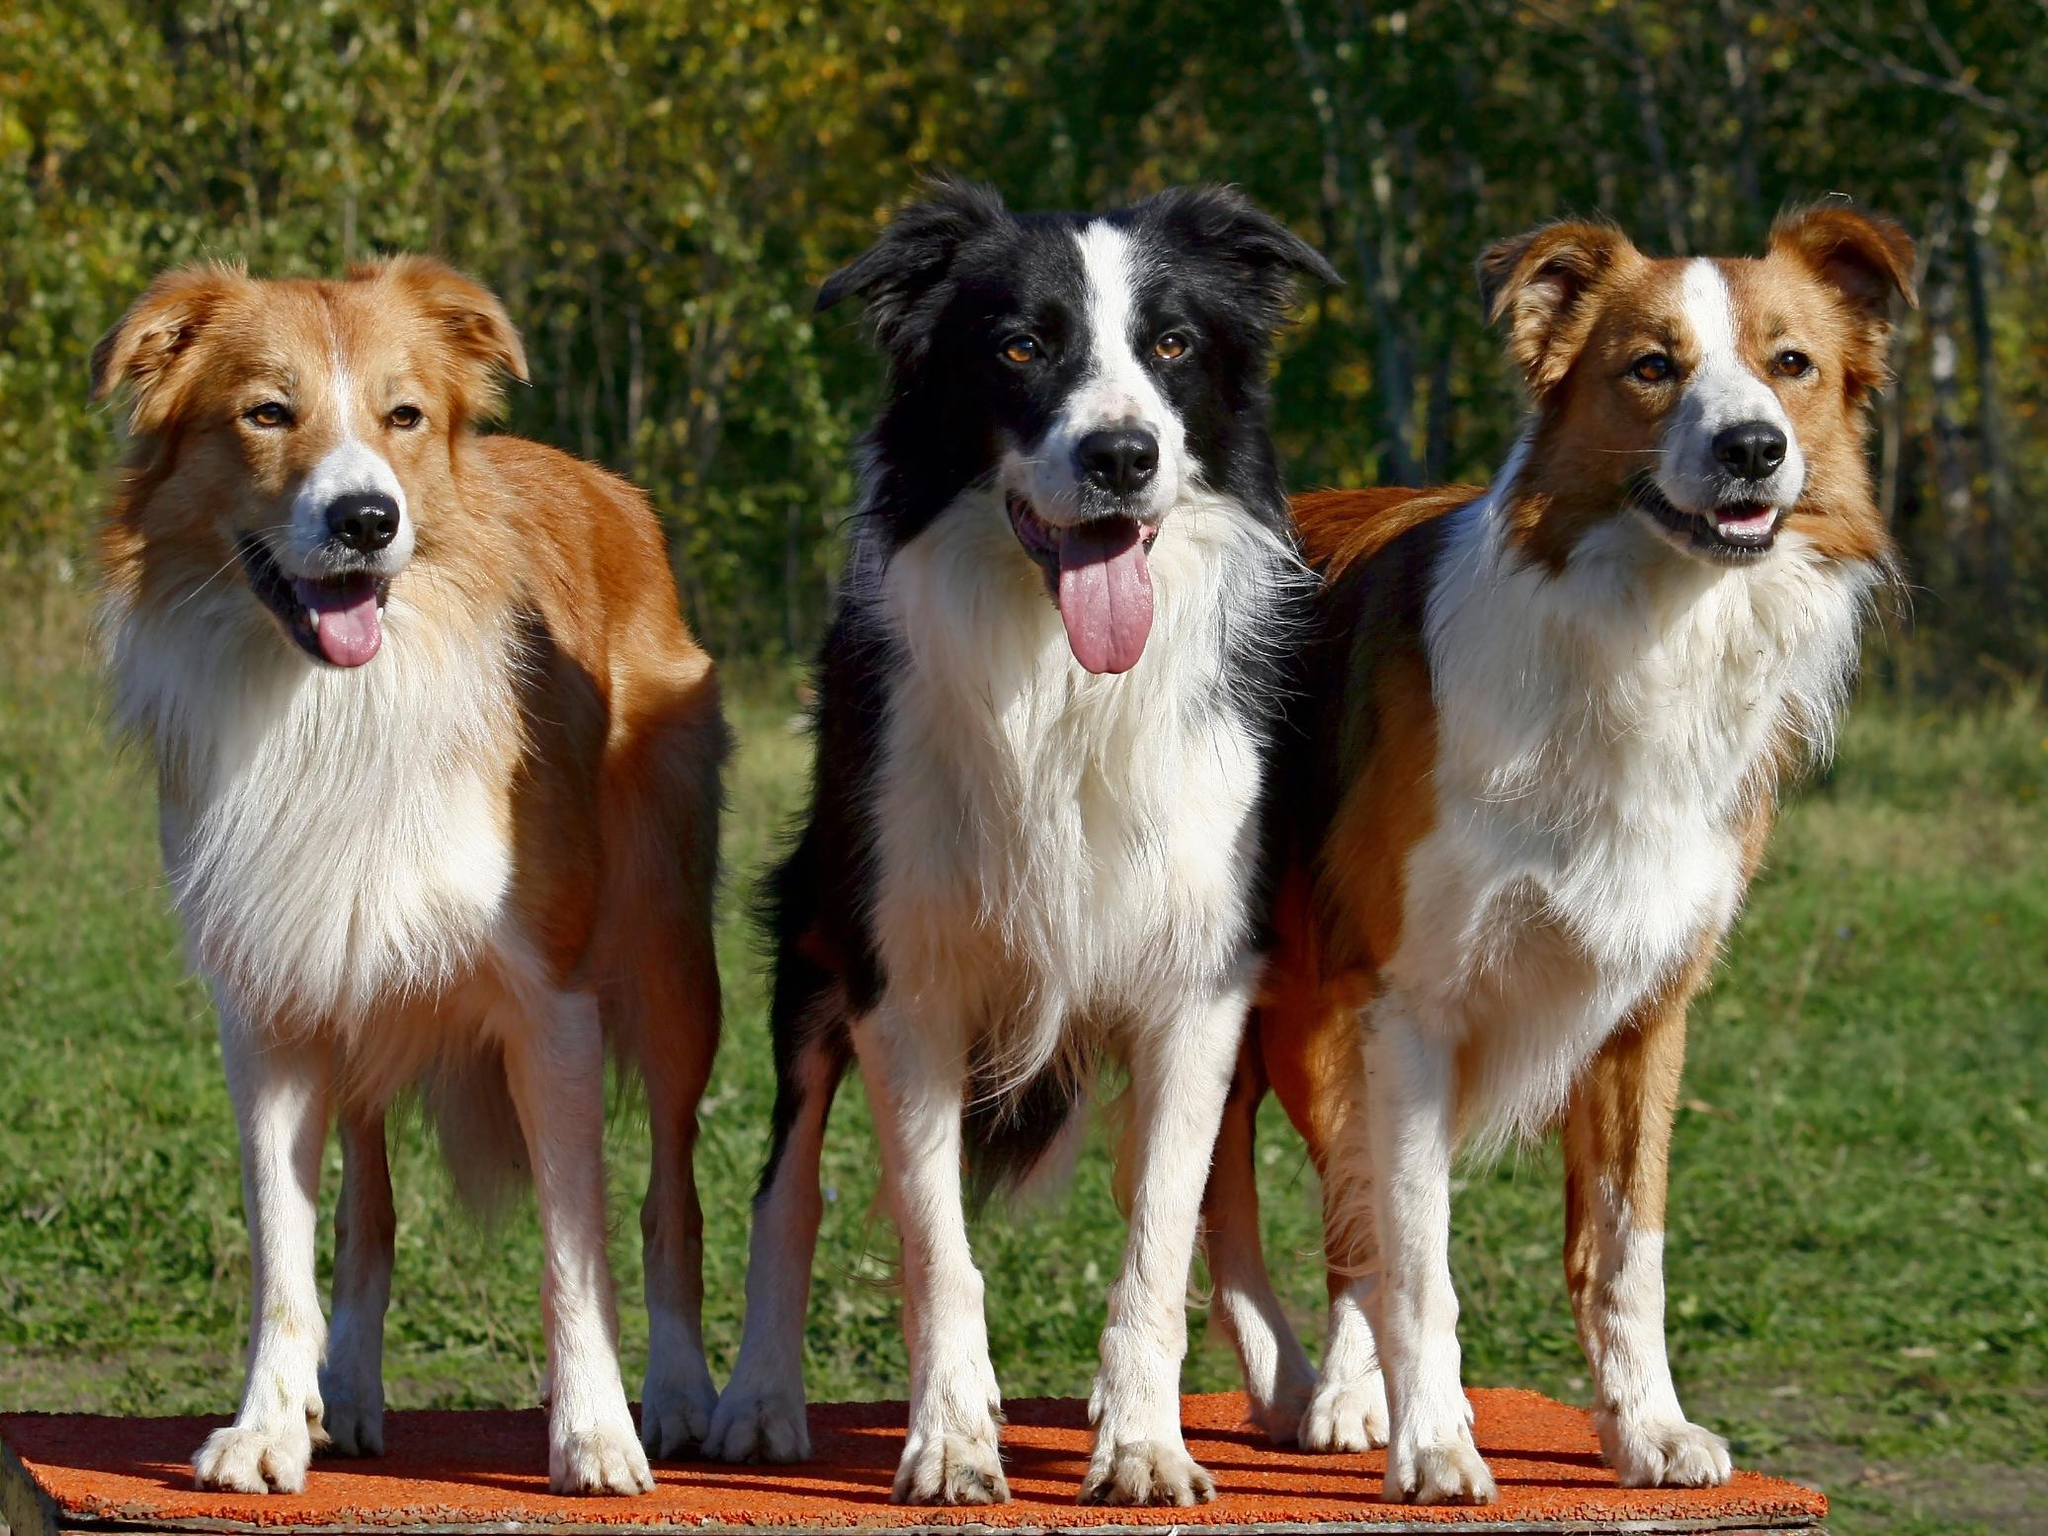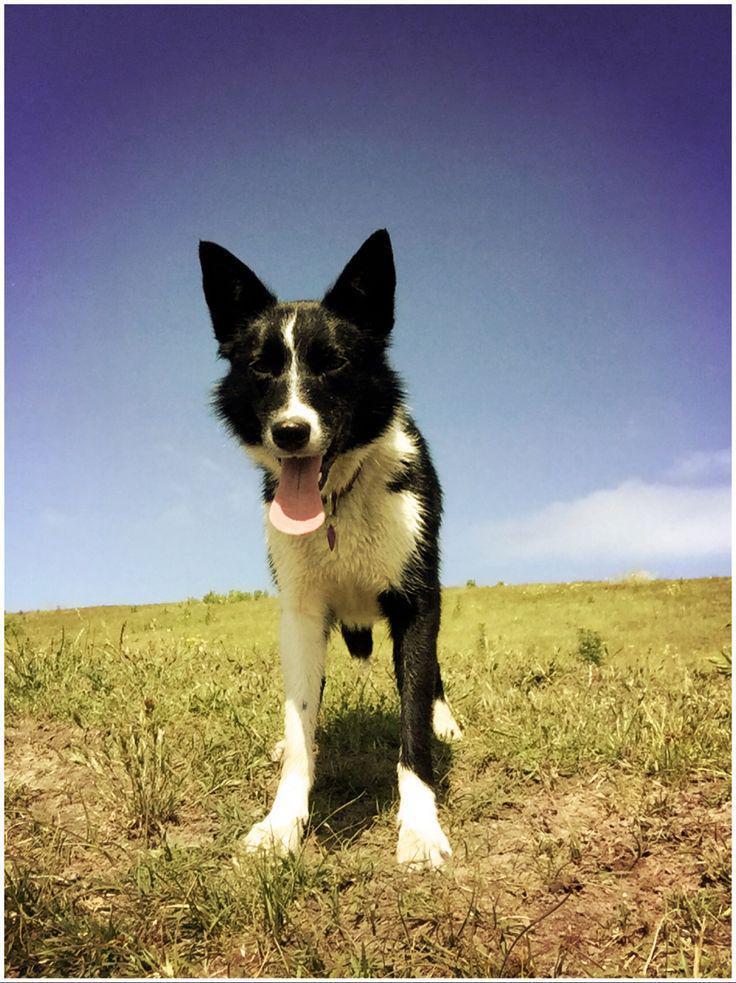The first image is the image on the left, the second image is the image on the right. For the images displayed, is the sentence "a body of water is visible behind a dog" factually correct? Answer yes or no. No. The first image is the image on the left, the second image is the image on the right. Assess this claim about the two images: "Exactly one dog is sitting.". Correct or not? Answer yes or no. No. 